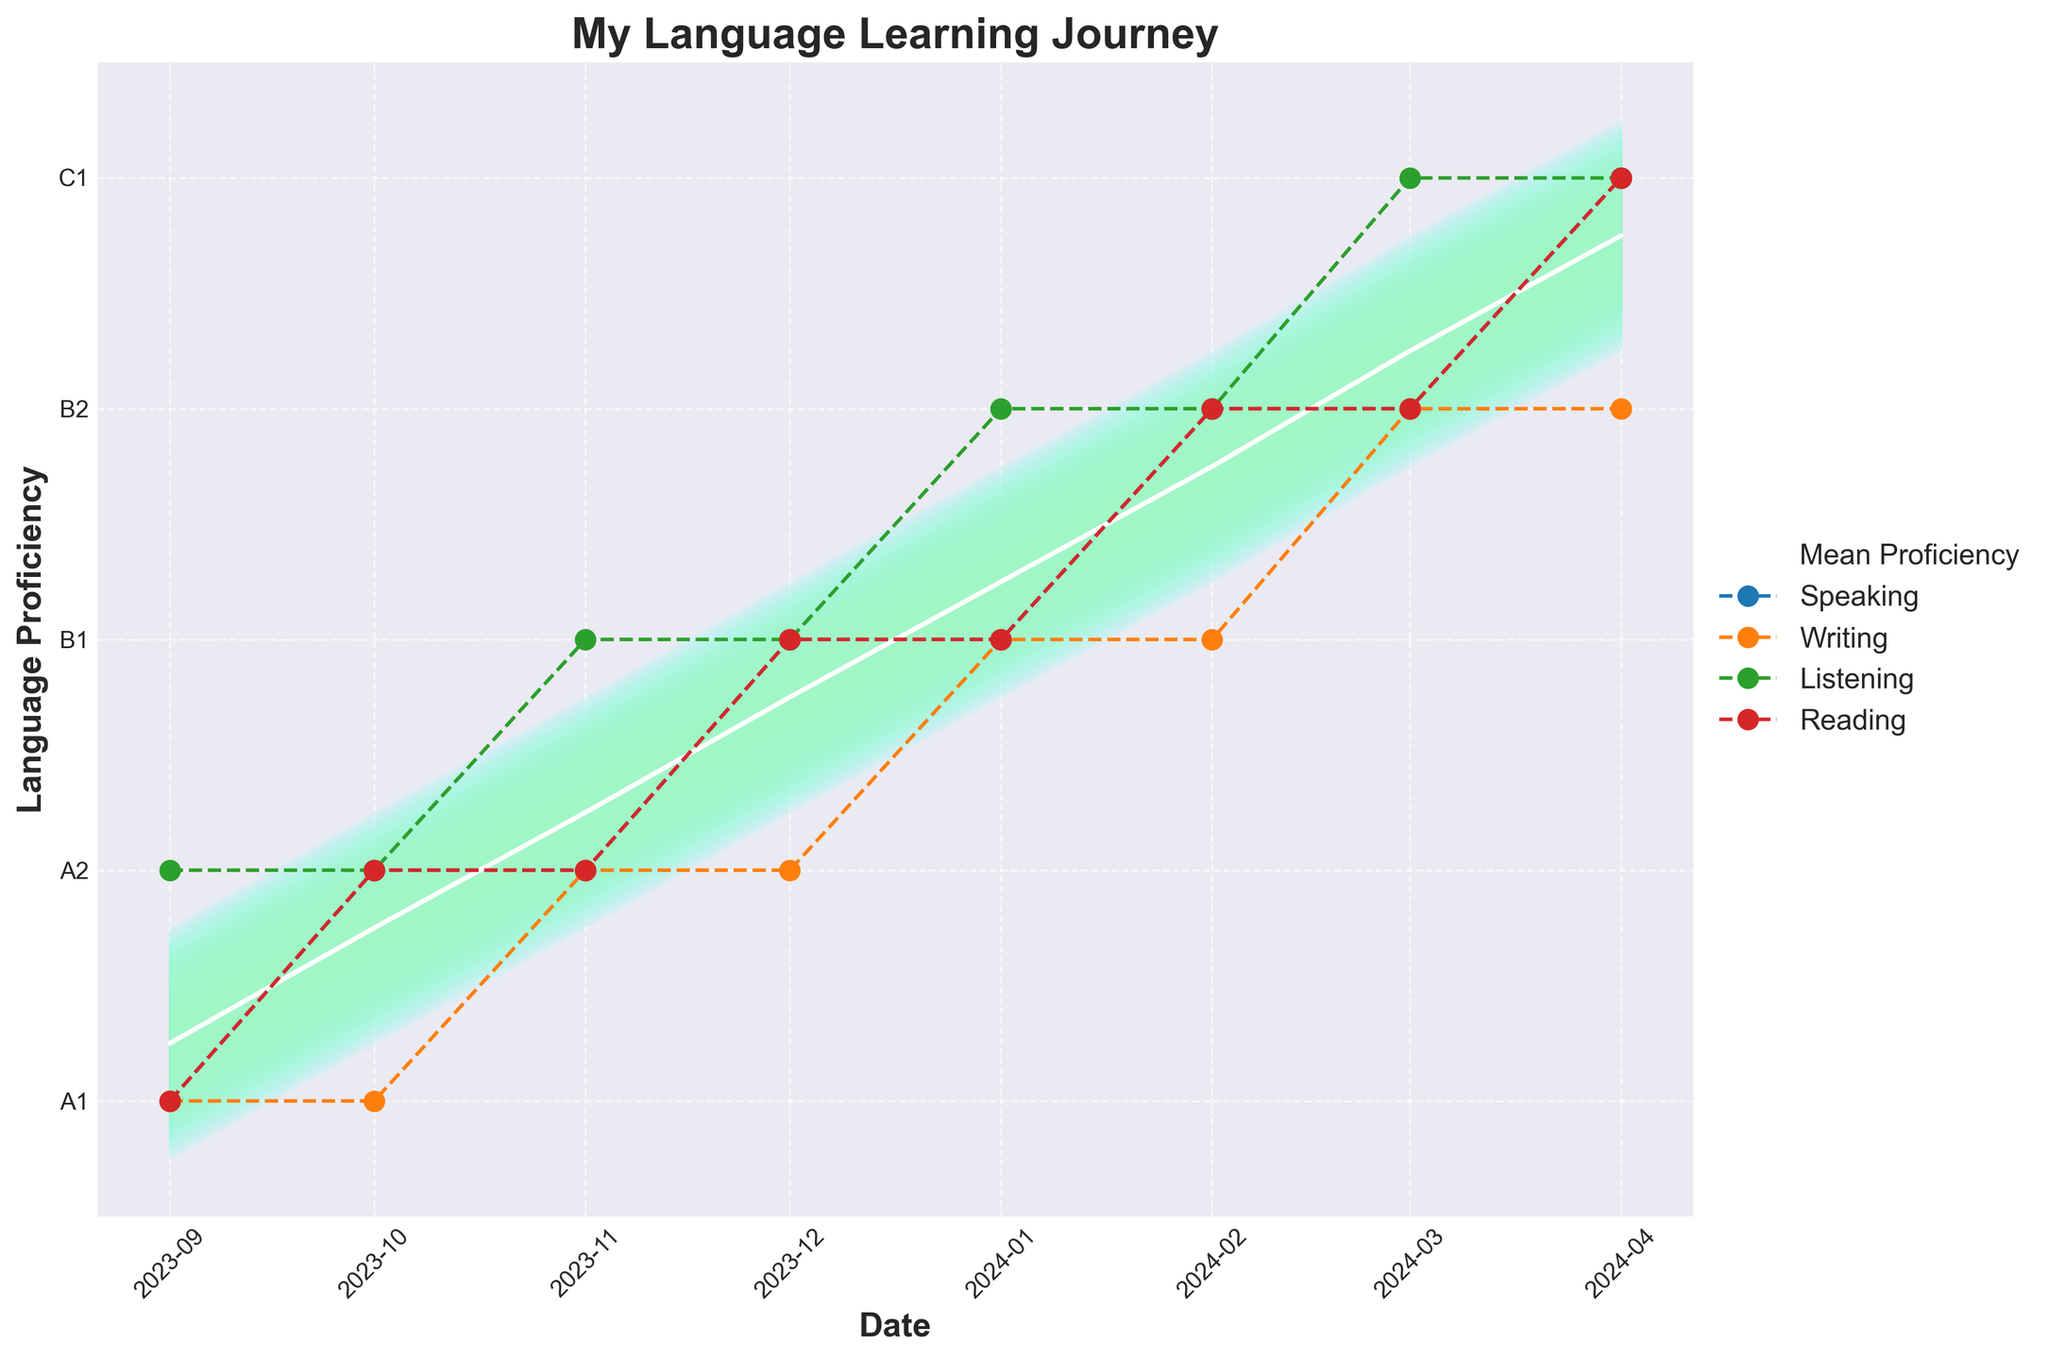What is the title of the plot? The title is usually placed at the top of the plot in larger, bold text. It directly provides a clear summary of what the visual data represents.
Answer: "My Language Learning Journey" How many proficiency levels are plotted for each date? The y-axis shows the range of proficiency levels from A1 to C1, indicating a total of 5 distinct proficiency levels possible (A1, A2, B1, B2, C1).
Answer: 5 What color represents the highest proficiency level in the fan chart? The color for the highest proficiency level (C1) can be found by looking at the topmost part of the chart or the darkest shade in the fan's gradient.
Answer: Light blue What was your listening proficiency level in January 2024? By finding January 2024 on the x-axis and tracing upwards to where the Listening line intersects, you can determine the proficiency level.
Answer: B2 Between which two months did your writing proficiency improve from A1 to A2? Trace the Writing line and observe the points of interest. Look for the transition from proficiency level A1 to A2 between the respective months.
Answer: September 2023 to November 2023 What is the mean proficiency level across all skills in April 2024? The plot averages the proficiency levels for Speaking, Writing, Listening, and Reading at each point in time. April 2024 shows these averaged into a single value.
Answer: C1 During which month did your average proficiency first reach B2? Look at where the mean proficiency line, shown in white, first intersects the B2 level on the y-axis.
Answer: February 2024 In which month is the gap between the highest and lowest proficiency levels the widest? Compare the vertical distance from highest to lowest skill levels at each month using the fan chart's spread. Observe where it's widest.
Answer: March 2024 Which skill shows the most consistent improvement over the recorded months? By examining the individual skill lines for stability and consistent upward trends, one can identify the most steadily improving skill.
Answer: Listening What trend do you observe in the mean proficiency line from September 2023 to April 2024? Observing the white mean proficiency line from start to end, note its general direction (upward, downward, constant).
Answer: Upward/train 